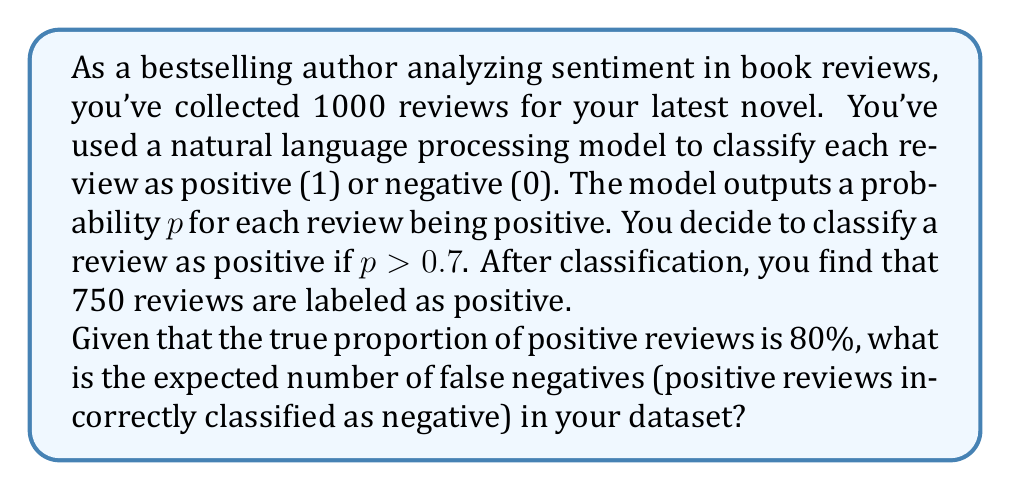Could you help me with this problem? Let's approach this step-by-step:

1) First, let's define our variables:
   - Total reviews: $N = 1000$
   - True proportion of positive reviews: $\theta = 0.8$
   - Number of reviews classified as positive: $P = 750$

2) The true number of positive reviews is:
   $$T = N \cdot \theta = 1000 \cdot 0.8 = 800$$

3) False negatives are positive reviews incorrectly classified as negative. To find this, we need to subtract the number of correctly classified positive reviews from the true number of positive reviews.

4) The number of reviews classified as negative is:
   $$N - P = 1000 - 750 = 250$$

5) The expected number of false negatives is:
   $$E[\text{False Negatives}] = T - (P \cdot \theta)$$

   This is because out of the 750 reviews classified as positive, we expect $\theta = 80\%$ of them to be truly positive.

6) Plugging in the values:
   $$E[\text{False Negatives}] = 800 - (750 \cdot 0.8) = 800 - 600 = 200$$

Therefore, the expected number of false negatives is 200.
Answer: 200 